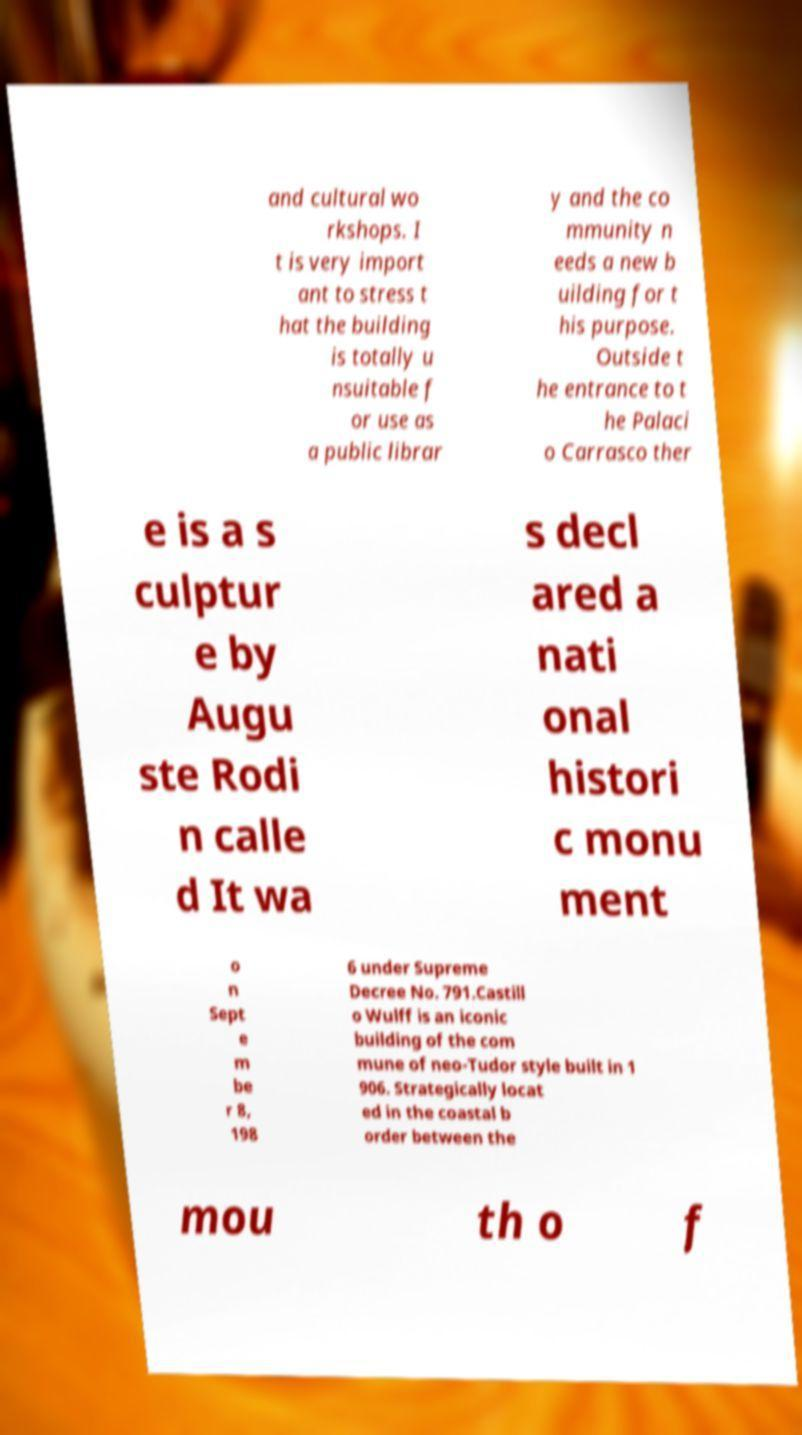Could you extract and type out the text from this image? and cultural wo rkshops. I t is very import ant to stress t hat the building is totally u nsuitable f or use as a public librar y and the co mmunity n eeds a new b uilding for t his purpose. Outside t he entrance to t he Palaci o Carrasco ther e is a s culptur e by Augu ste Rodi n calle d It wa s decl ared a nati onal histori c monu ment o n Sept e m be r 8, 198 6 under Supreme Decree No. 791.Castill o Wulff is an iconic building of the com mune of neo-Tudor style built in 1 906. Strategically locat ed in the coastal b order between the mou th o f 